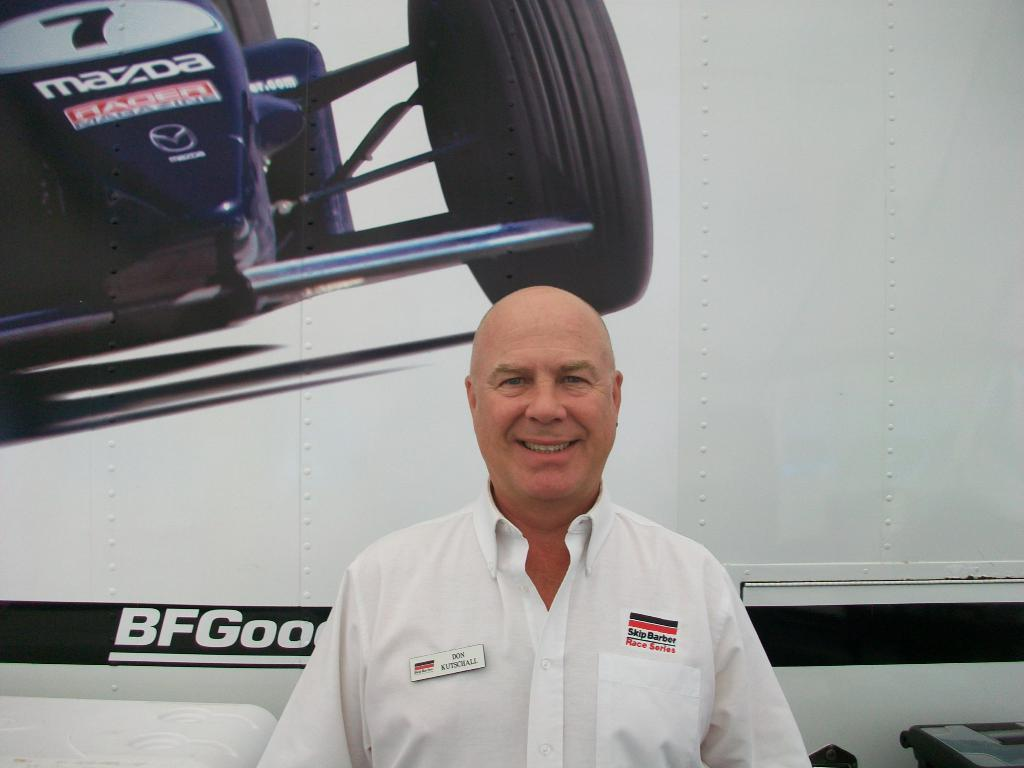<image>
Render a clear and concise summary of the photo. a man smiling with Skip Barber Race series written on his shirt. 